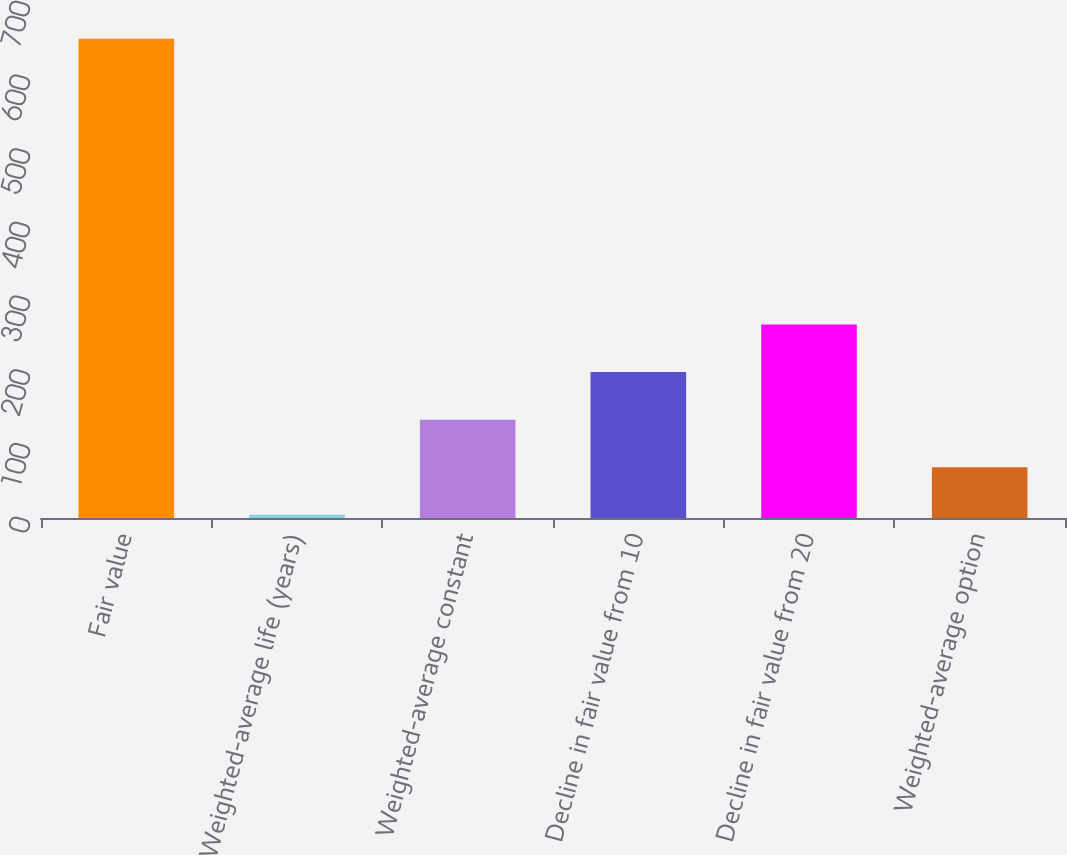<chart> <loc_0><loc_0><loc_500><loc_500><bar_chart><fcel>Fair value<fcel>Weighted-average life (years)<fcel>Weighted-average constant<fcel>Decline in fair value from 10<fcel>Decline in fair value from 20<fcel>Weighted-average option<nl><fcel>650<fcel>4.3<fcel>133.44<fcel>198.01<fcel>262.58<fcel>68.87<nl></chart> 